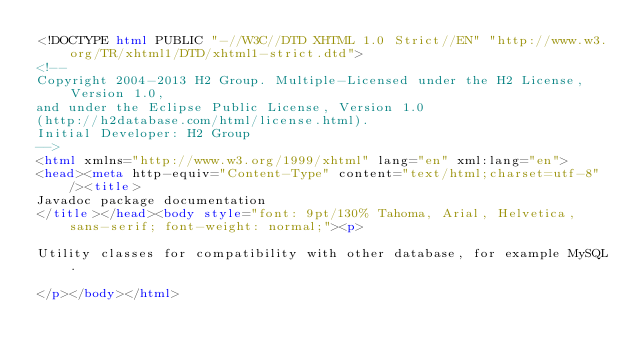<code> <loc_0><loc_0><loc_500><loc_500><_HTML_><!DOCTYPE html PUBLIC "-//W3C//DTD XHTML 1.0 Strict//EN" "http://www.w3.org/TR/xhtml1/DTD/xhtml1-strict.dtd">
<!--
Copyright 2004-2013 H2 Group. Multiple-Licensed under the H2 License, Version 1.0,
and under the Eclipse Public License, Version 1.0
(http://h2database.com/html/license.html).
Initial Developer: H2 Group
-->
<html xmlns="http://www.w3.org/1999/xhtml" lang="en" xml:lang="en">
<head><meta http-equiv="Content-Type" content="text/html;charset=utf-8" /><title>
Javadoc package documentation
</title></head><body style="font: 9pt/130% Tahoma, Arial, Helvetica, sans-serif; font-weight: normal;"><p>

Utility classes for compatibility with other database, for example MySQL.

</p></body></html></code> 